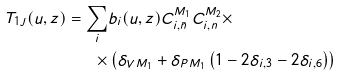<formula> <loc_0><loc_0><loc_500><loc_500>T _ { 1 J } ( u , z ) = \sum _ { i } & b _ { i } ( u , z ) C _ { i , \bar { n } } ^ { M _ { 1 } } C _ { i , n } ^ { M _ { 2 } } \times \\ \times & \left ( \delta _ { V M _ { 1 } } + \delta _ { P M _ { 1 } } \left ( 1 - 2 \delta _ { i , 3 } - 2 \delta _ { i , 6 } \right ) \right )</formula> 